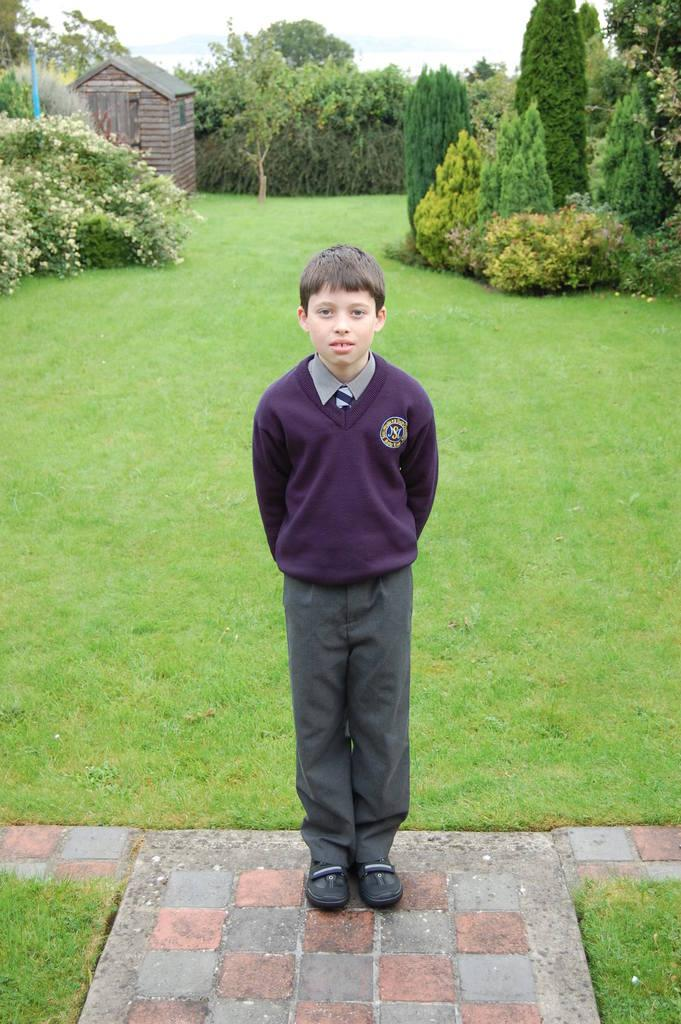Who is the main subject in the image? There is a boy in the image. What is the boy's position in relation to the ground? The boy is standing on the ground. What type of vegetation can be seen in the image? There is grass visible in the image. What provides shade in the image? There is a shade in the image. What can be seen in the background of the image? There are trees and the sky visible in the background of the image. What religion is the boy practicing in the image? There is no indication of any religious practice in the image; it simply shows a boy standing on the ground with a shade and trees in the background. 